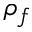Convert formula to latex. <formula><loc_0><loc_0><loc_500><loc_500>\rho _ { f }</formula> 